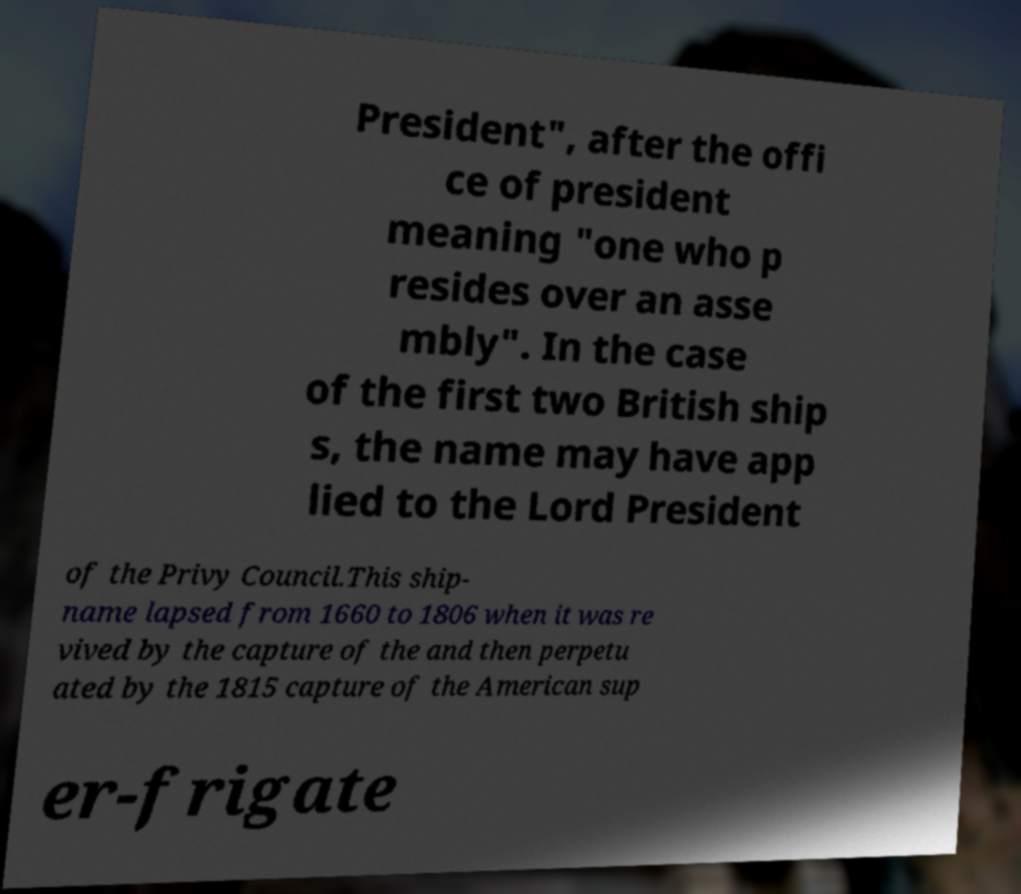Please read and relay the text visible in this image. What does it say? President", after the offi ce of president meaning "one who p resides over an asse mbly". In the case of the first two British ship s, the name may have app lied to the Lord President of the Privy Council.This ship- name lapsed from 1660 to 1806 when it was re vived by the capture of the and then perpetu ated by the 1815 capture of the American sup er-frigate 